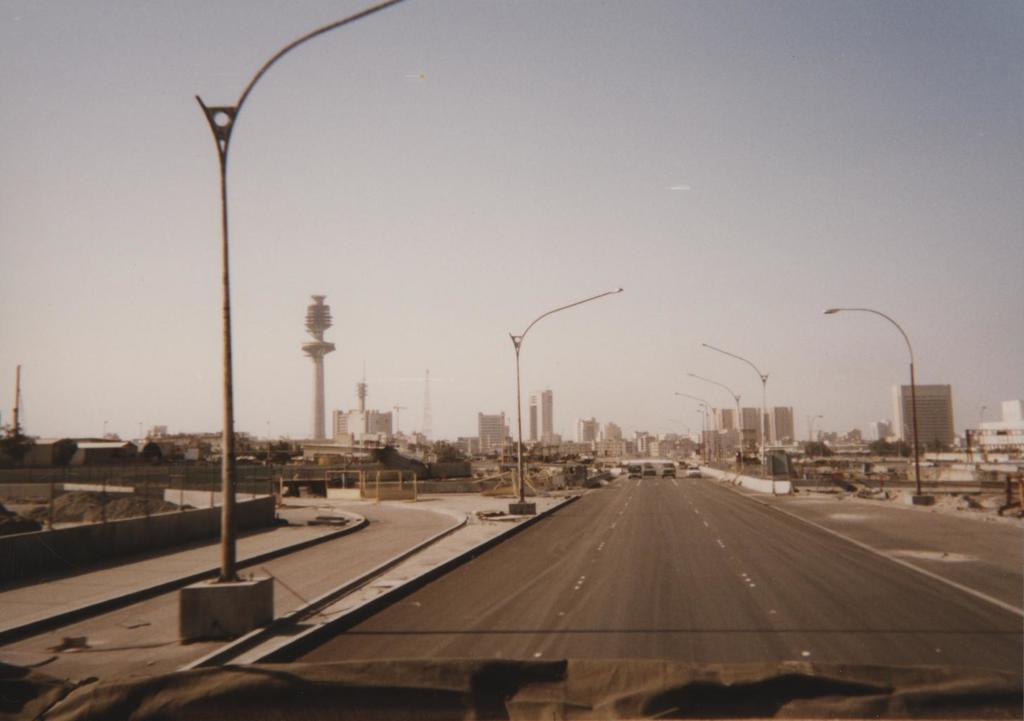In one or two sentences, can you explain what this image depicts? In the image we can see the road and vehicles on the road. There are even light poles, buildings and the sky. 